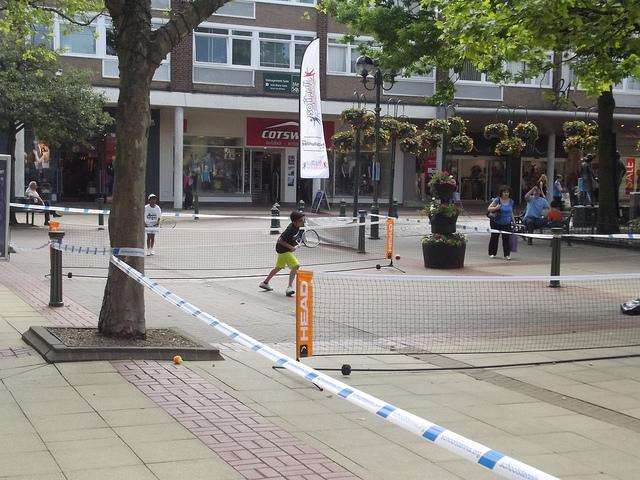Who is playing tennis with the boy wearing yellow pants? woman 